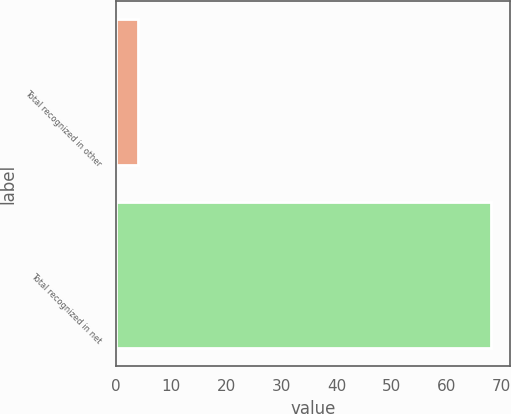Convert chart to OTSL. <chart><loc_0><loc_0><loc_500><loc_500><bar_chart><fcel>Total recognized in other<fcel>Total recognized in net<nl><fcel>4<fcel>68<nl></chart> 